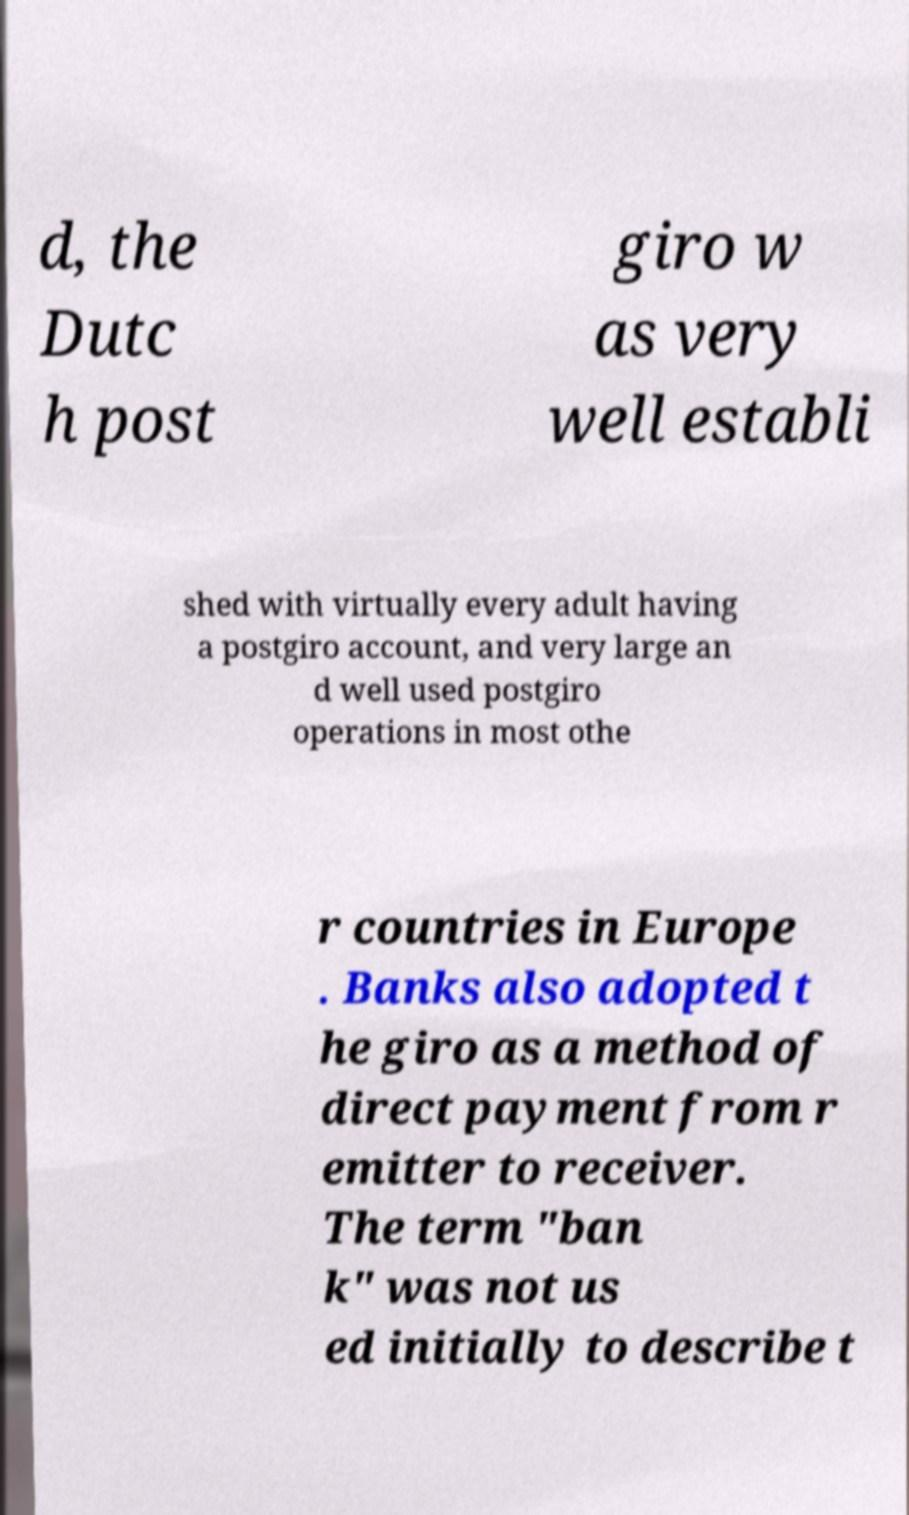There's text embedded in this image that I need extracted. Can you transcribe it verbatim? d, the Dutc h post giro w as very well establi shed with virtually every adult having a postgiro account, and very large an d well used postgiro operations in most othe r countries in Europe . Banks also adopted t he giro as a method of direct payment from r emitter to receiver. The term "ban k" was not us ed initially to describe t 